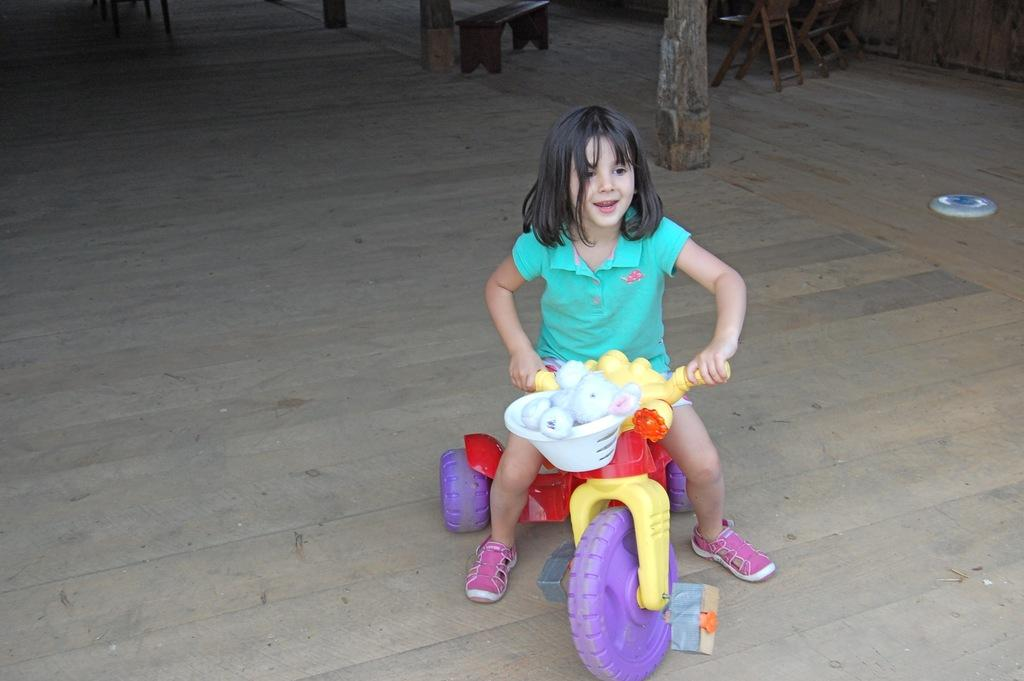What is the main subject of the image? There is a child in the image. What is the child doing in the image? The child is sitting on a toy. What type of furniture is present in the image? There is a chair in the image. What is the material of the floor in the image? The floor is made of wood. What is the child wearing in the image? The child is wearing a green dress. Can you hear the child's toes laughing in the image? There is no sound in the image, and toes do not have the ability to laugh. 